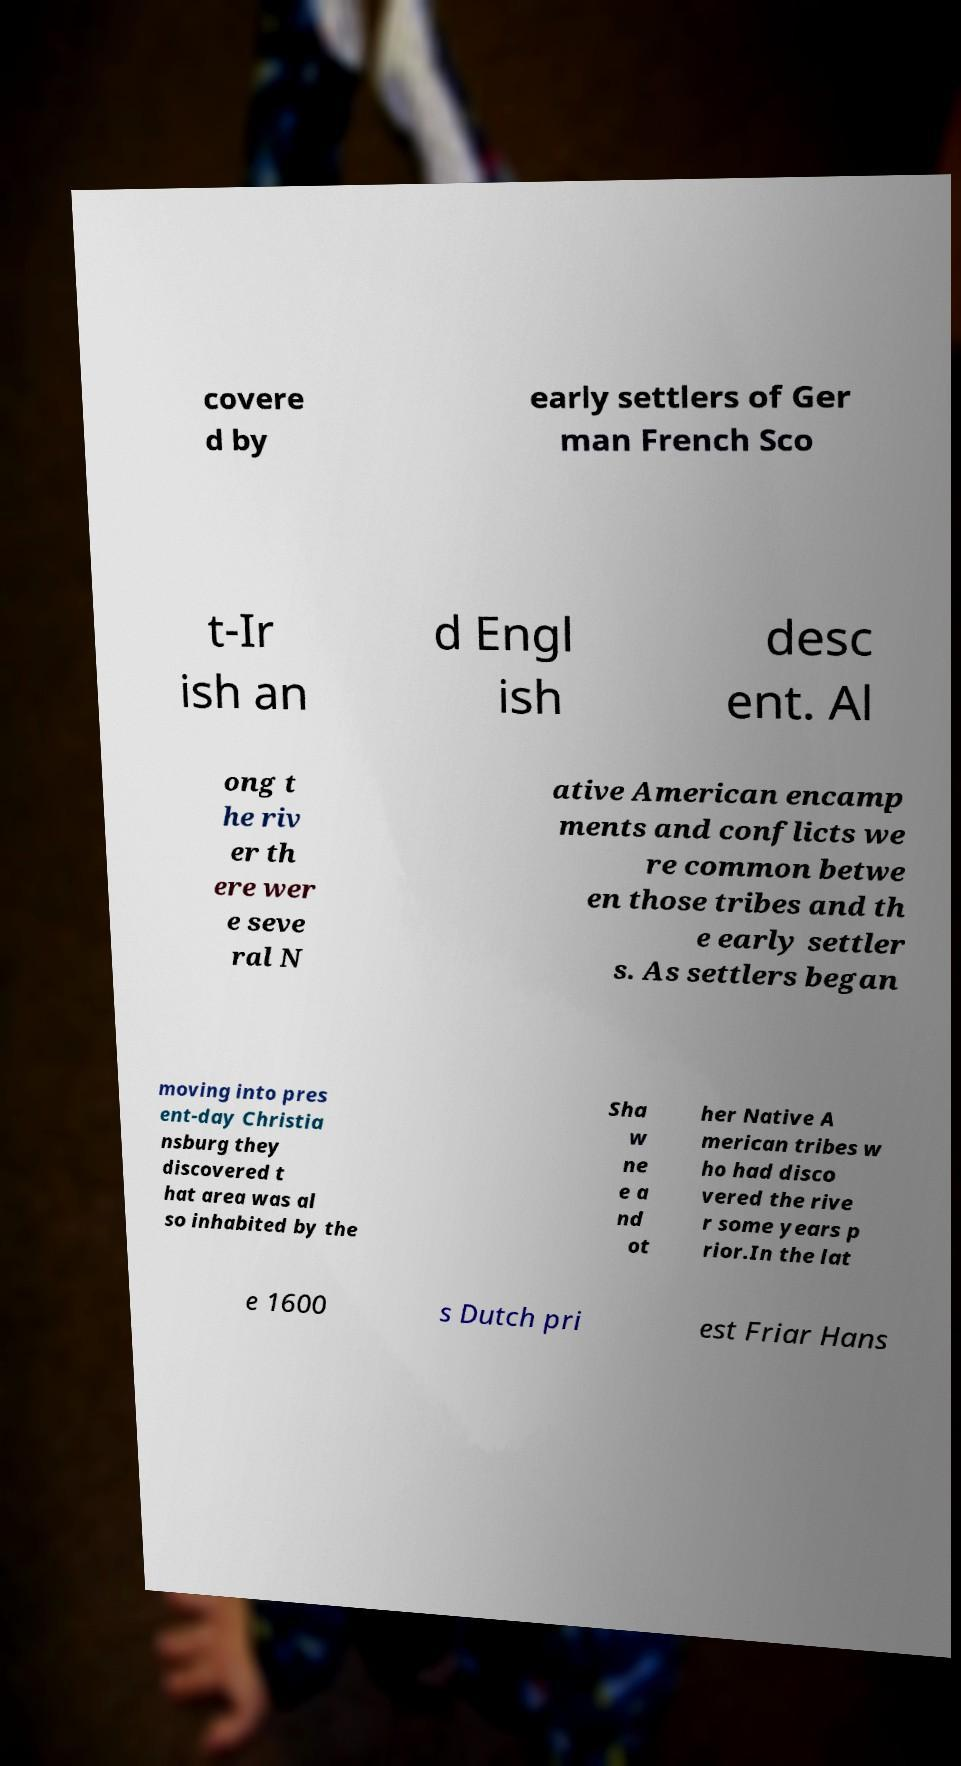For documentation purposes, I need the text within this image transcribed. Could you provide that? covere d by early settlers of Ger man French Sco t-Ir ish an d Engl ish desc ent. Al ong t he riv er th ere wer e seve ral N ative American encamp ments and conflicts we re common betwe en those tribes and th e early settler s. As settlers began moving into pres ent-day Christia nsburg they discovered t hat area was al so inhabited by the Sha w ne e a nd ot her Native A merican tribes w ho had disco vered the rive r some years p rior.In the lat e 1600 s Dutch pri est Friar Hans 